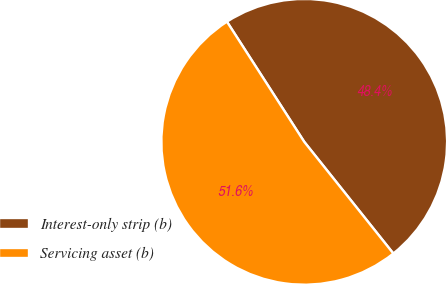Convert chart. <chart><loc_0><loc_0><loc_500><loc_500><pie_chart><fcel>Interest-only strip (b)<fcel>Servicing asset (b)<nl><fcel>48.38%<fcel>51.62%<nl></chart> 